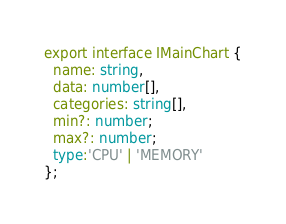<code> <loc_0><loc_0><loc_500><loc_500><_TypeScript_>export interface IMainChart {
  name: string,
  data: number[],
  categories: string[],
  min?: number;
  max?: number;
  type:'CPU' | 'MEMORY'
};
</code> 